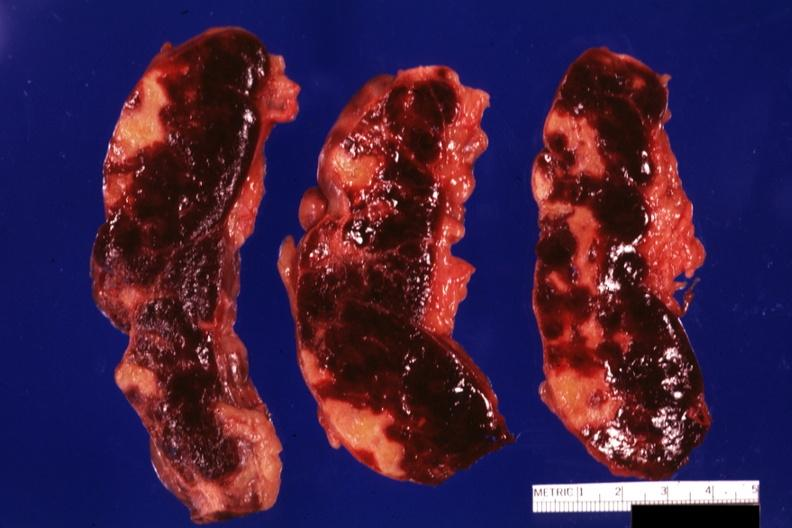how many cut does this image show sections many lesions several days of age?
Answer the question using a single word or phrase. Three 